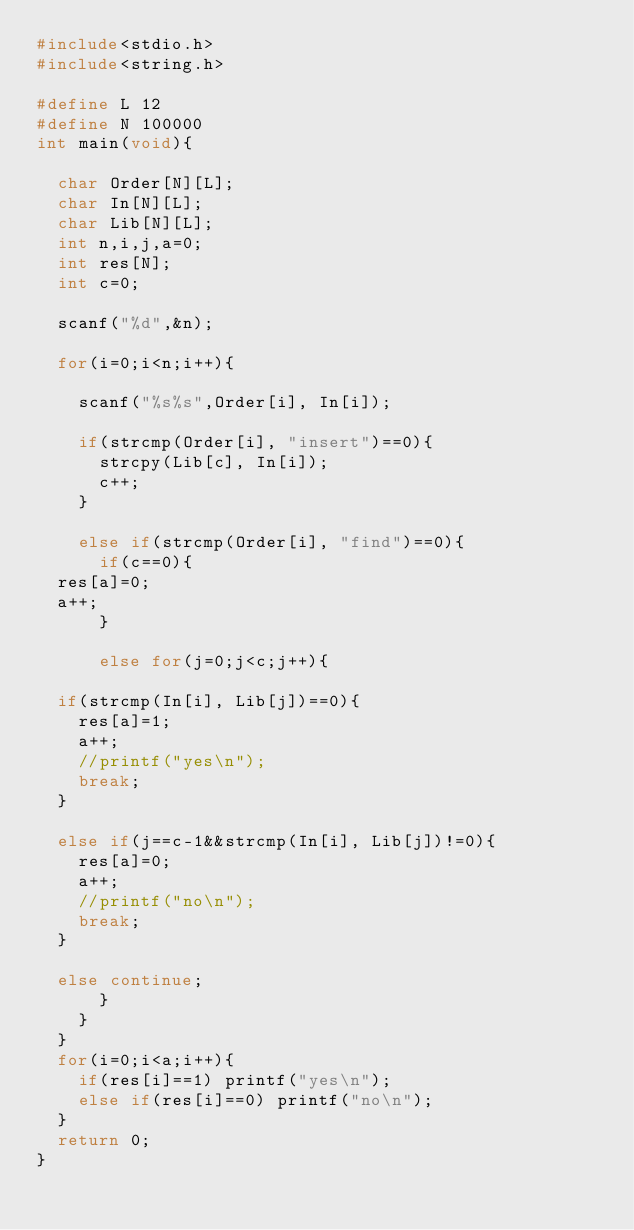Convert code to text. <code><loc_0><loc_0><loc_500><loc_500><_C_>#include<stdio.h>
#include<string.h>

#define L 12
#define N 100000
int main(void){
  
  char Order[N][L];
  char In[N][L];
  char Lib[N][L];
  int n,i,j,a=0;
  int res[N];
  int c=0;
  
  scanf("%d",&n);
  
  for(i=0;i<n;i++){
    
    scanf("%s%s",Order[i], In[i]);
    
    if(strcmp(Order[i], "insert")==0){
      strcpy(Lib[c], In[i]);
      c++;
    }
    
    else if(strcmp(Order[i], "find")==0){
      if(c==0){
	res[a]=0;
	a++;
      }
     
      else for(j=0;j<c;j++){
	
	if(strcmp(In[i], Lib[j])==0){
	  res[a]=1;
	  a++;
	  //printf("yes\n");
	  break;
	}
	
	else if(j==c-1&&strcmp(In[i], Lib[j])!=0){
	  res[a]=0;
	  a++;
	  //printf("no\n");
	  break;
	}
	
	else continue;
      }
    }
  }
  for(i=0;i<a;i++){
    if(res[i]==1) printf("yes\n");
    else if(res[i]==0) printf("no\n");
  }
  return 0;
}

</code> 